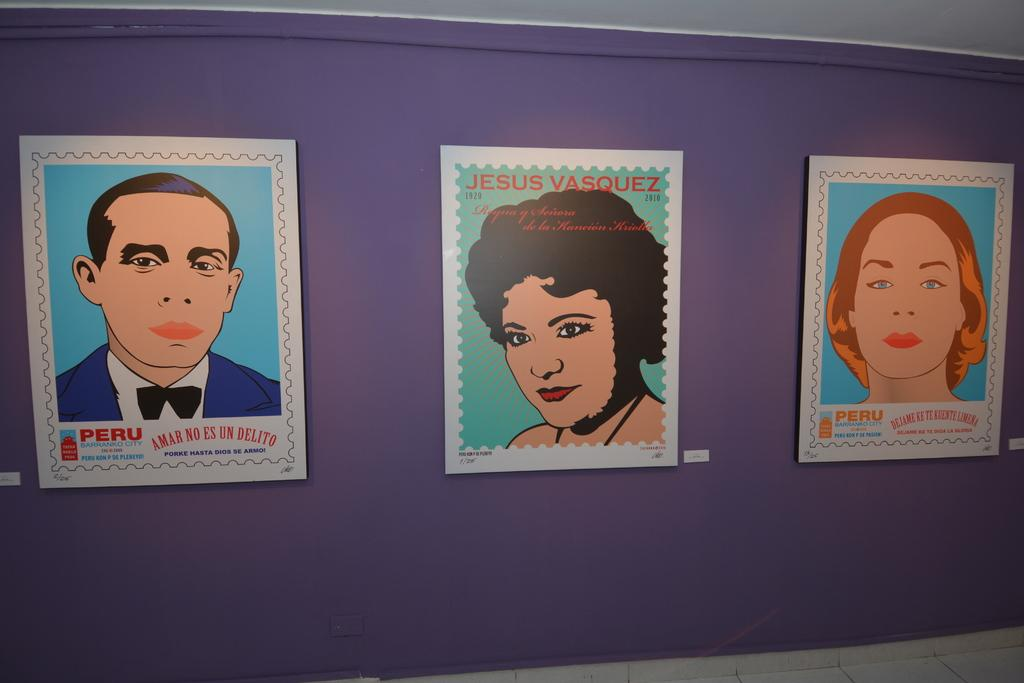What type of posters are visible in the image? There are animation posters in the image. What do the posters depict? The posters depict people. Where are the posters located? The posters are on a wall. What type of neck accessory is worn by the people depicted on the posters? There is no information about neck accessories in the image, as it only shows animation posters on a wall. 